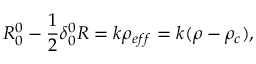Convert formula to latex. <formula><loc_0><loc_0><loc_500><loc_500>R _ { 0 } ^ { 0 } - \frac { 1 } { 2 } \delta _ { 0 } ^ { 0 } R = k \rho _ { e f f } = k ( \rho - \rho _ { c } ) ,</formula> 